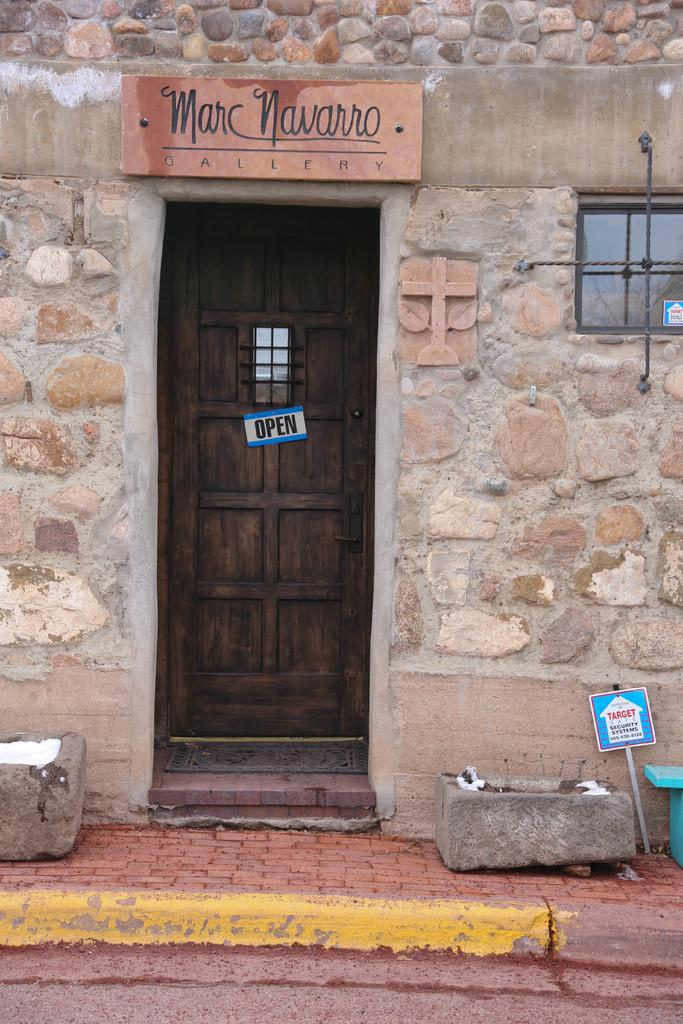What is attached to the door in the image? There is a small board on the door. What is attached to the wall in the image? There is a name board on the wall. What can be seen on the right side of the image? There is a window on the right side. What is on the floor in the image? There is a mat on the floor. What is present on the footpath in the image? There are rocks on the footpath. What is attached to a stick in the image? There is a board on a stick. What is the general description of an object in the image? There is an object in the image. What year is depicted on the scarecrow in the image? There is no scarecrow present in the image. How many people are visible in the image? There is no person visible in the image. 